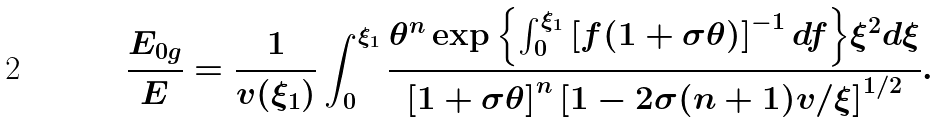<formula> <loc_0><loc_0><loc_500><loc_500>\frac { E _ { 0 g } } { E } = \frac { 1 } { v ( \xi _ { 1 } ) } \int _ { 0 } ^ { \xi _ { 1 } } \frac { \theta ^ { n } \exp { \left \{ \int _ { 0 } ^ { \xi _ { 1 } } \left [ f ( 1 + \sigma \theta ) \right ] ^ { - 1 } d f \right \} } \xi ^ { 2 } d \xi } { \left [ 1 + \sigma \theta \right ] ^ { n } \left [ 1 - 2 \sigma ( n + 1 ) v / \xi \right ] ^ { 1 / 2 } } .</formula> 